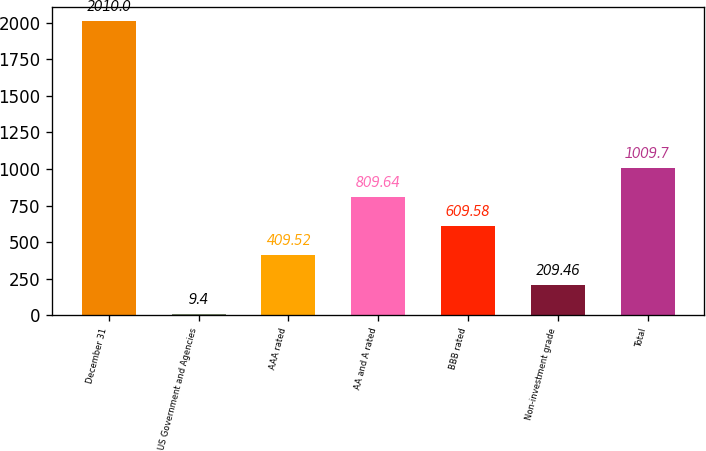Convert chart to OTSL. <chart><loc_0><loc_0><loc_500><loc_500><bar_chart><fcel>December 31<fcel>US Government and Agencies<fcel>AAA rated<fcel>AA and A rated<fcel>BBB rated<fcel>Non-investment grade<fcel>Total<nl><fcel>2010<fcel>9.4<fcel>409.52<fcel>809.64<fcel>609.58<fcel>209.46<fcel>1009.7<nl></chart> 